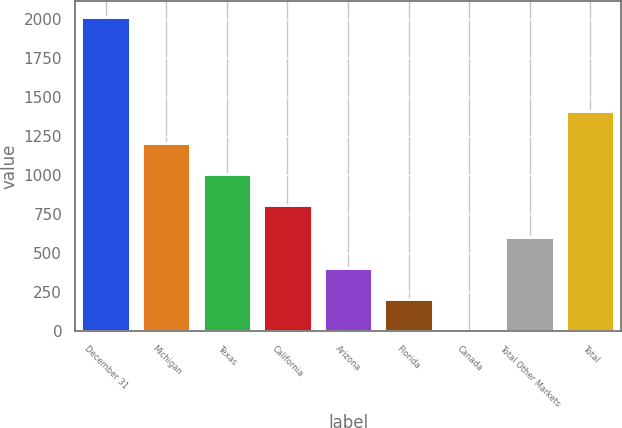Convert chart to OTSL. <chart><loc_0><loc_0><loc_500><loc_500><bar_chart><fcel>December 31<fcel>Michigan<fcel>Texas<fcel>California<fcel>Arizona<fcel>Florida<fcel>Canada<fcel>Total Other Markets<fcel>Total<nl><fcel>2014<fcel>1208.8<fcel>1007.5<fcel>806.2<fcel>403.6<fcel>202.3<fcel>1<fcel>604.9<fcel>1410.1<nl></chart> 